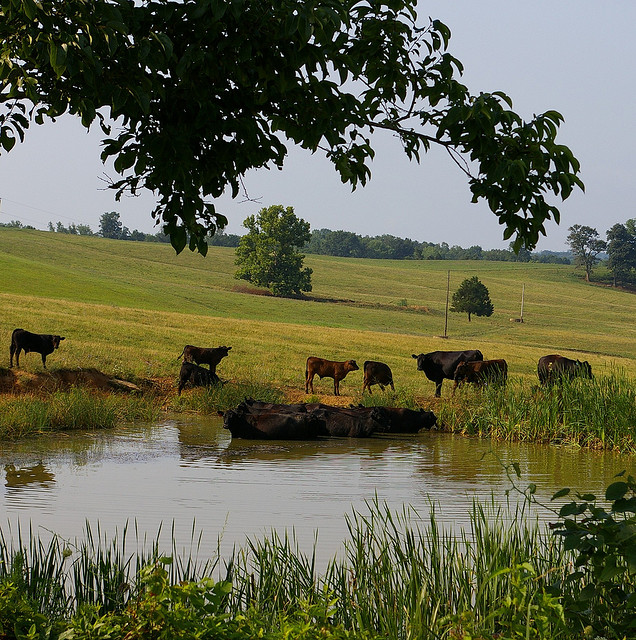<image>Is this a farm? It is ambiguous if this is a farm or not. Is this a farm? Yes, it is a farm. 